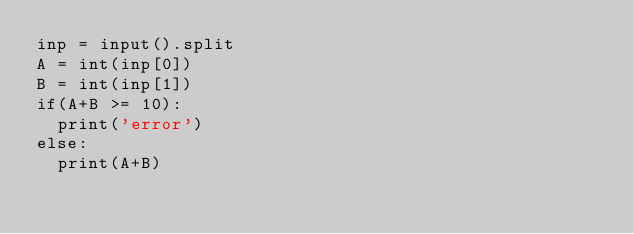Convert code to text. <code><loc_0><loc_0><loc_500><loc_500><_Python_>inp = input().split
A = int(inp[0])
B = int(inp[1])
if(A+B >= 10):
  print('error')
else:
  print(A+B)</code> 